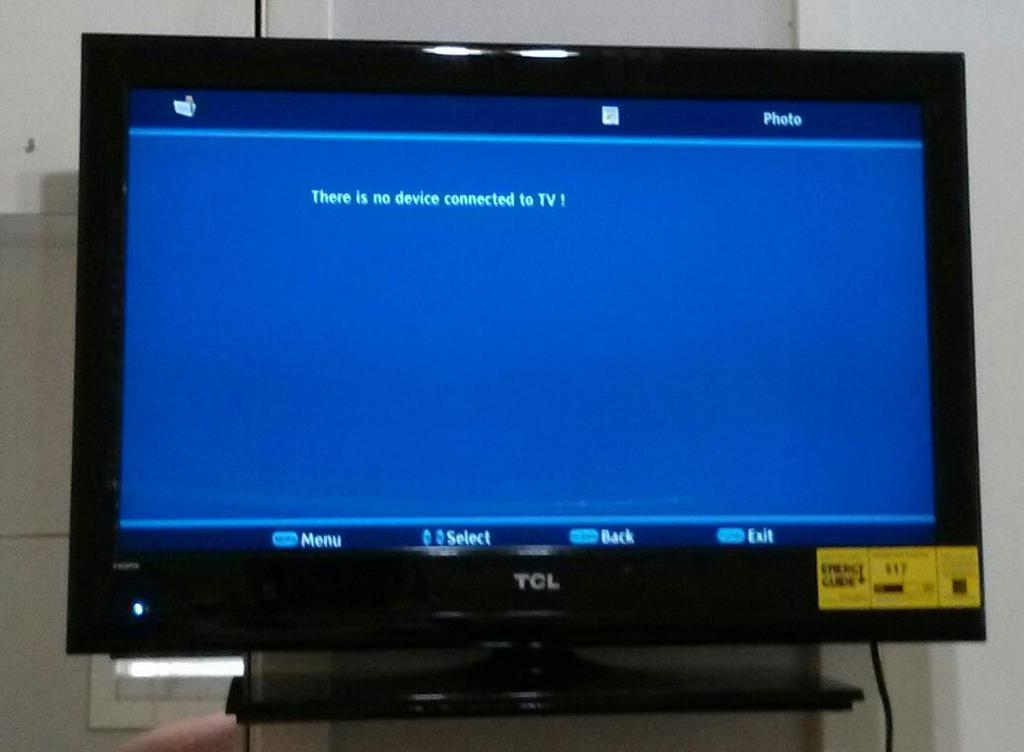Provide a one-sentence caption for the provided image. A black VCL TV showing a blue screen that says there is no device connected to TV. 